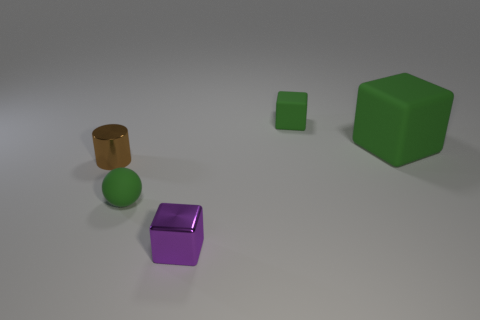There is a block that is on the right side of the tiny green thing that is behind the matte thing to the left of the purple metallic thing; what size is it?
Ensure brevity in your answer.  Large. There is a green ball that is the same size as the brown object; what material is it?
Provide a succinct answer. Rubber. Is there a blue metallic cylinder that has the same size as the sphere?
Provide a succinct answer. No. Does the big green thing have the same shape as the brown shiny object?
Keep it short and to the point. No. Is there a tiny matte object that is in front of the ball to the right of the small metal cylinder to the left of the large thing?
Give a very brief answer. No. How many other objects are there of the same color as the big matte object?
Provide a succinct answer. 2. Do the green rubber cube that is behind the big green object and the metallic thing behind the rubber sphere have the same size?
Your response must be concise. Yes. Are there an equal number of blocks that are behind the large green object and green spheres that are behind the small brown metallic object?
Your answer should be very brief. No. Are there any other things that have the same material as the big green block?
Offer a terse response. Yes. Does the green matte sphere have the same size as the thing behind the large block?
Offer a terse response. Yes. 